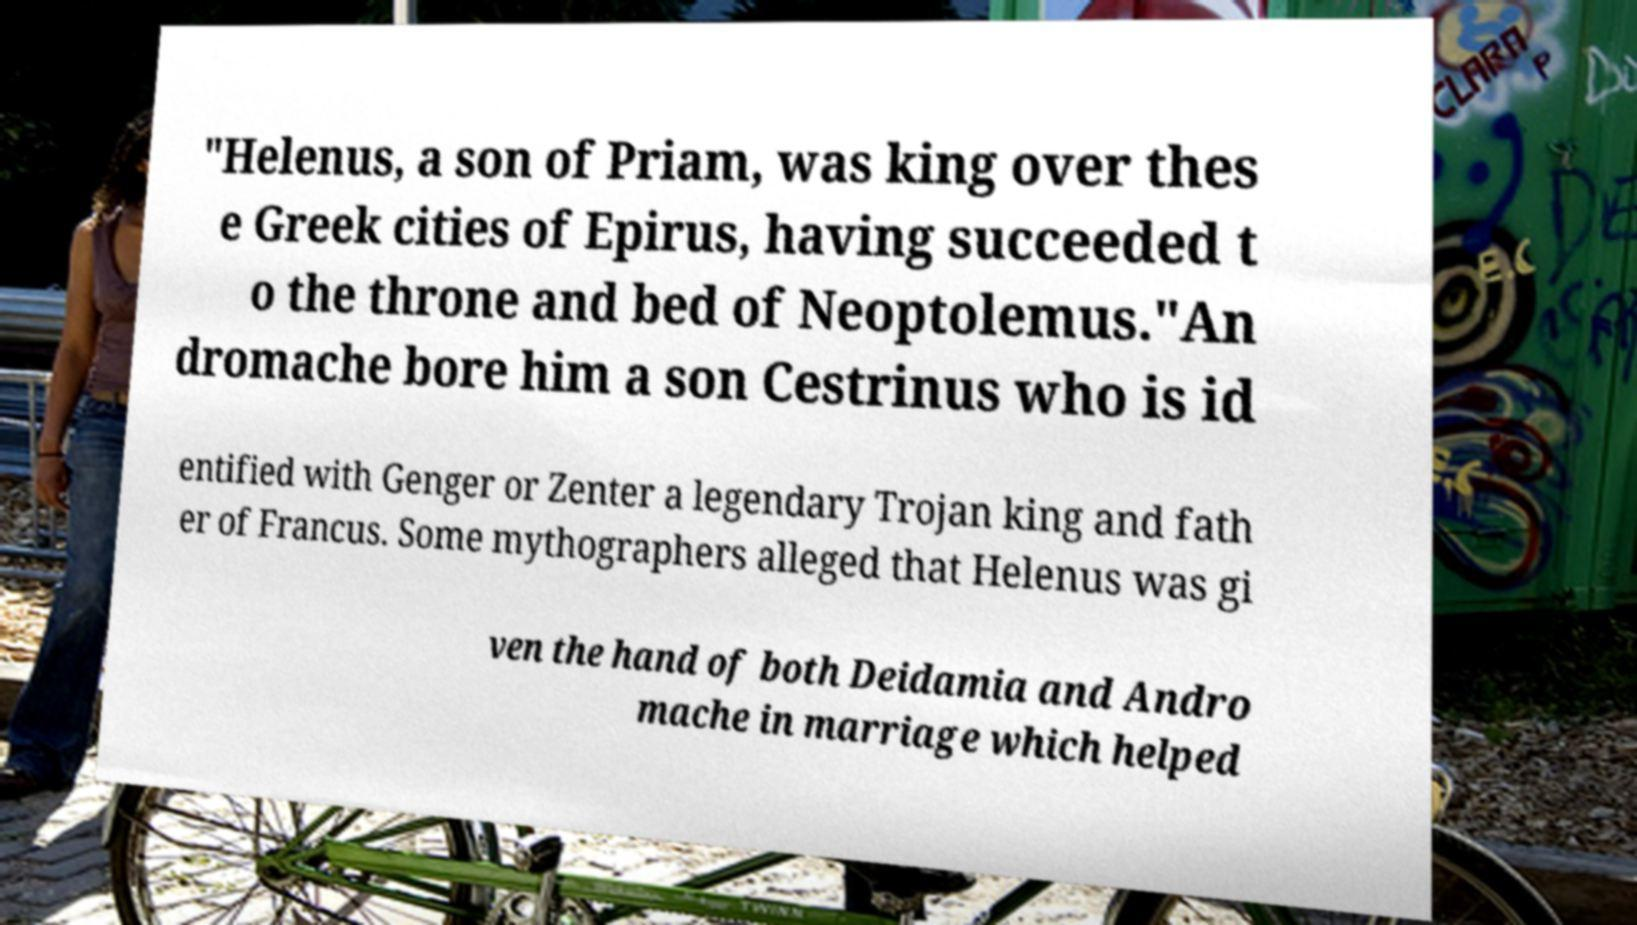Could you assist in decoding the text presented in this image and type it out clearly? "Helenus, a son of Priam, was king over thes e Greek cities of Epirus, having succeeded t o the throne and bed of Neoptolemus."An dromache bore him a son Cestrinus who is id entified with Genger or Zenter a legendary Trojan king and fath er of Francus. Some mythographers alleged that Helenus was gi ven the hand of both Deidamia and Andro mache in marriage which helped 